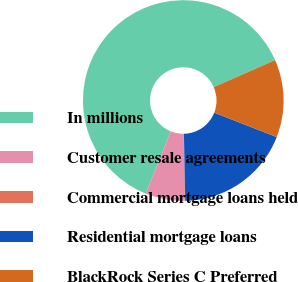<chart> <loc_0><loc_0><loc_500><loc_500><pie_chart><fcel>In millions<fcel>Customer resale agreements<fcel>Commercial mortgage loans held<fcel>Residential mortgage loans<fcel>BlackRock Series C Preferred<nl><fcel>62.3%<fcel>6.31%<fcel>0.09%<fcel>18.76%<fcel>12.53%<nl></chart> 